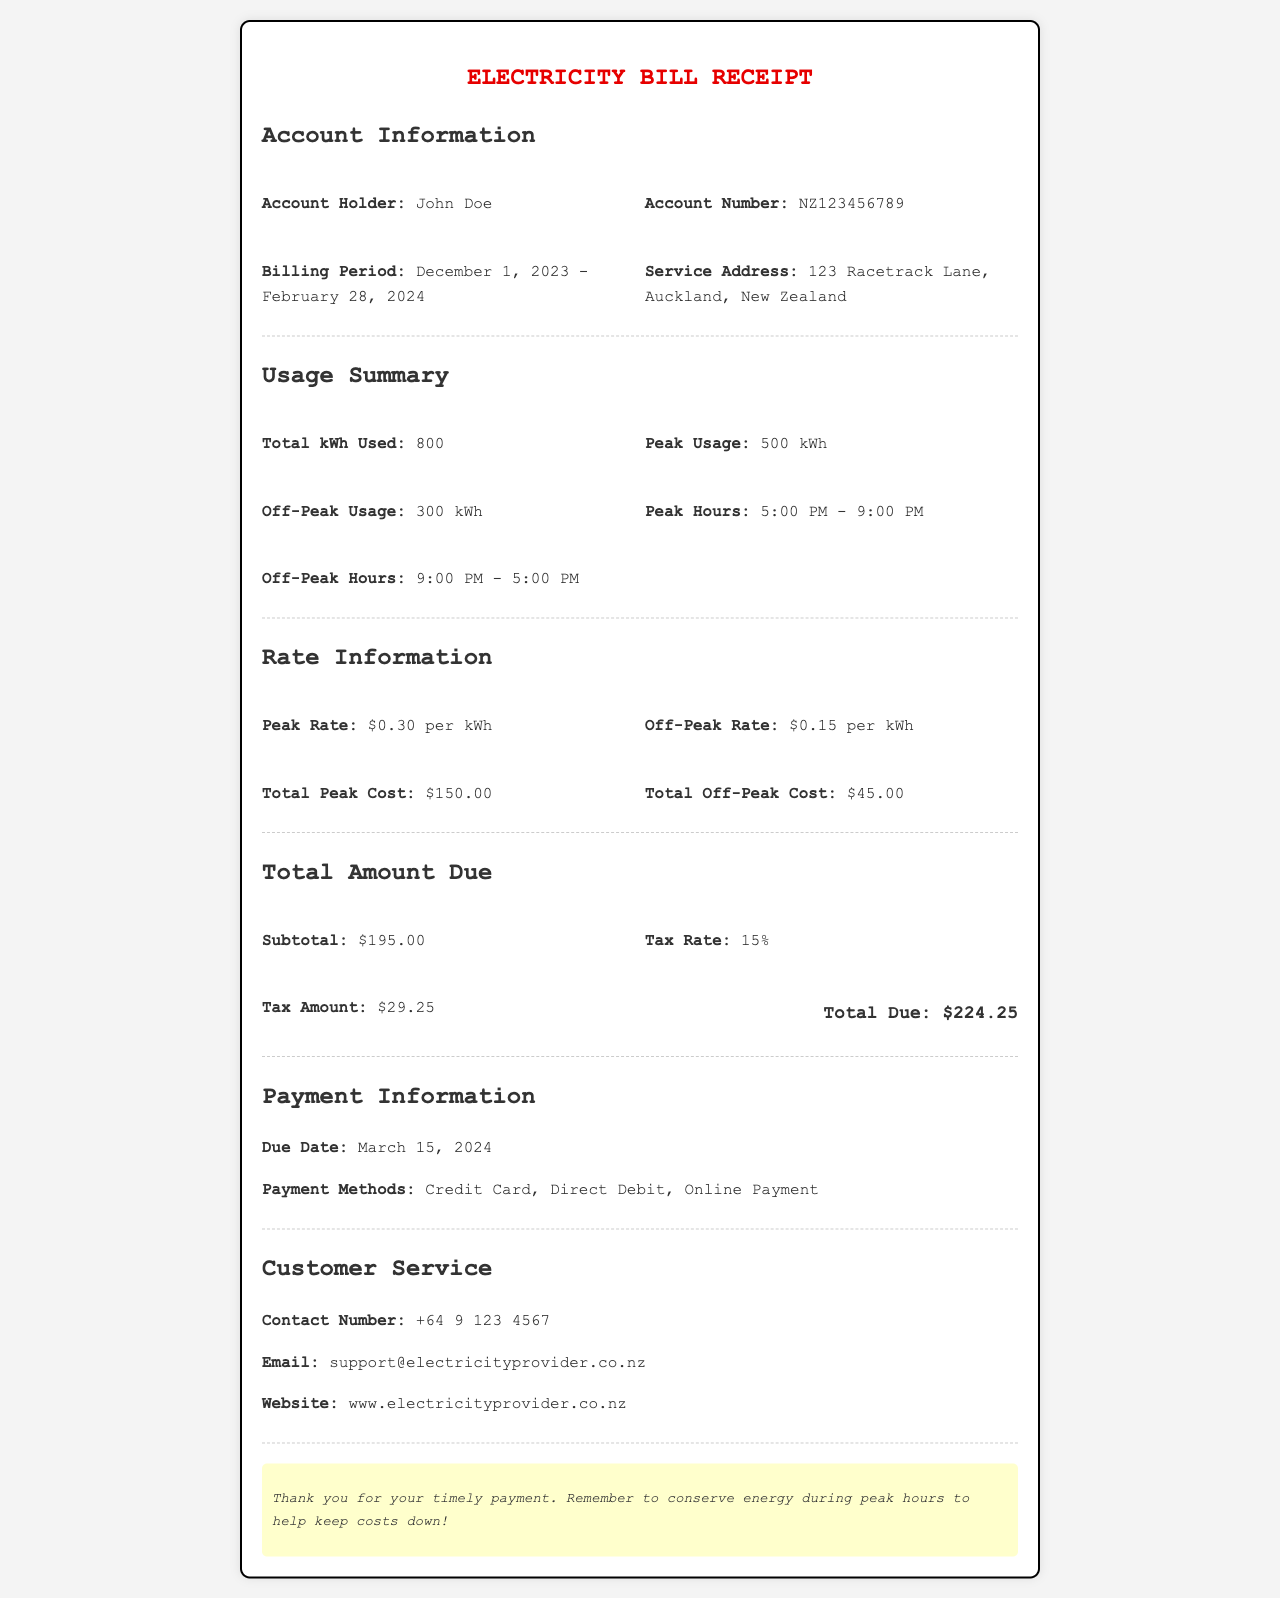What is the account holder's name? The document states the account holder's name in the Account Information section.
Answer: John Doe What is the total kWh used during the billing period? The total kWh used is indicated in the Usage Summary section.
Answer: 800 What is the peak usage in kWh? The peak usage is provided in the Usage Summary section.
Answer: 500 kWh What is the off-peak usage in kWh? The off-peak usage is listed in the Usage Summary section.
Answer: 300 kWh What is the due date for the payment? The due date is found in the Payment Information section.
Answer: March 15, 2024 What is the total amount due? The total amount due is mentioned in the Total Amount Due section.
Answer: $224.25 What is the peak rate per kWh? The peak rate per kWh is given in the Rate Information section.
Answer: $0.30 per kWh What is the contact number for customer service? The customer service contact number is specified in the Customer Service section.
Answer: +64 9 123 4567 How much is the tax amount? The tax amount is presented in the Total Amount Due section.
Answer: $29.25 